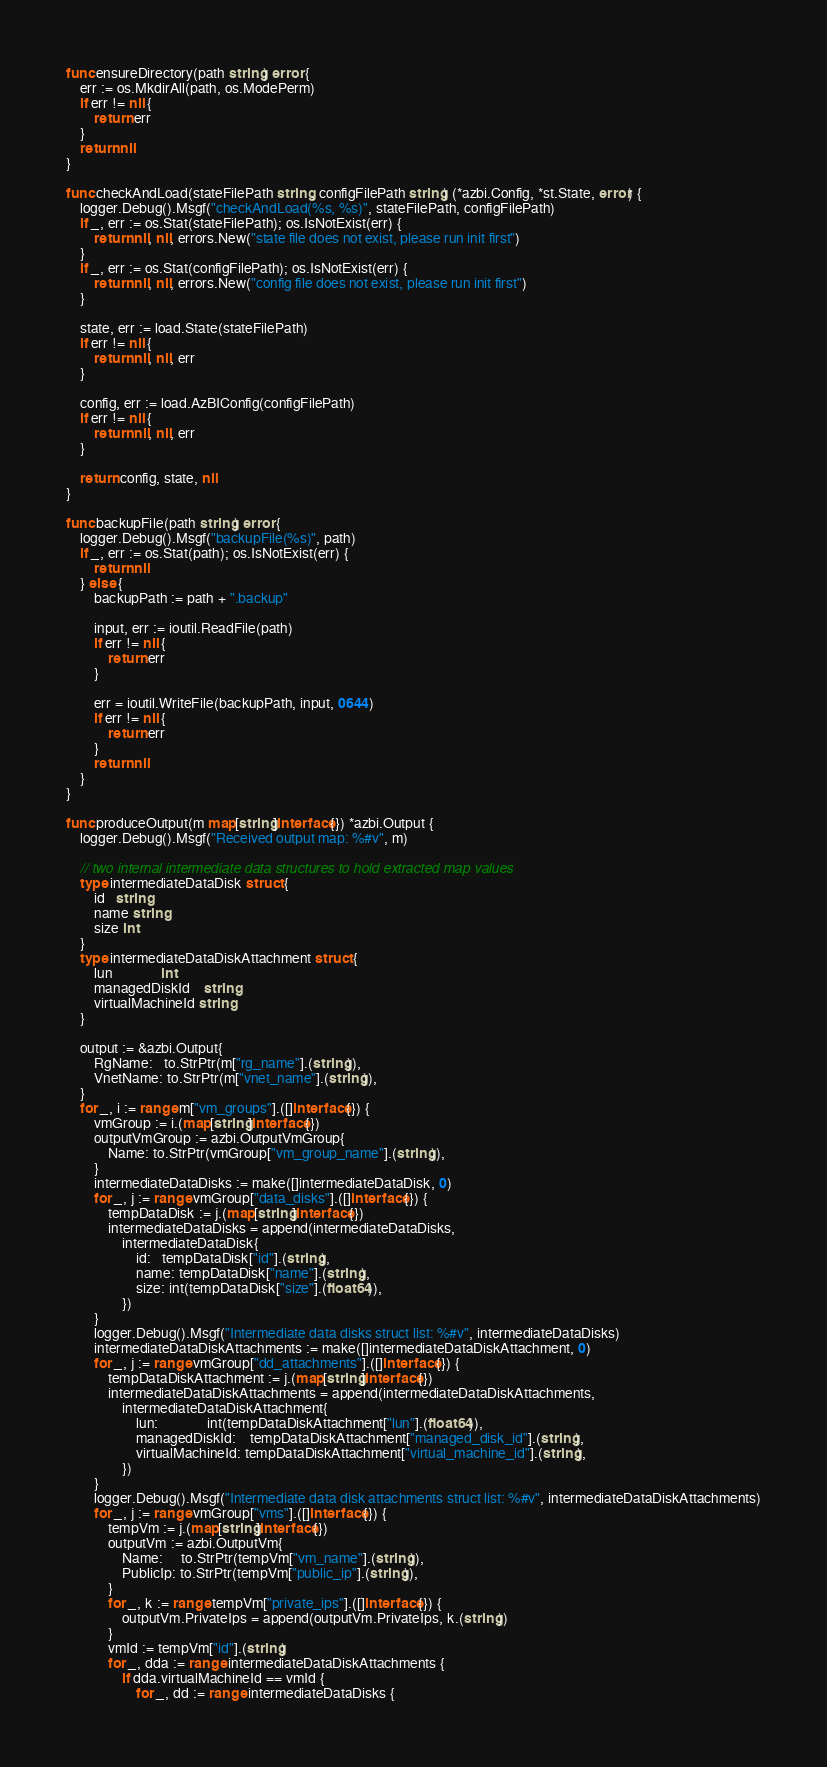Convert code to text. <code><loc_0><loc_0><loc_500><loc_500><_Go_>func ensureDirectory(path string) error {
	err := os.MkdirAll(path, os.ModePerm)
	if err != nil {
		return err
	}
	return nil
}

func checkAndLoad(stateFilePath string, configFilePath string) (*azbi.Config, *st.State, error) {
	logger.Debug().Msgf("checkAndLoad(%s, %s)", stateFilePath, configFilePath)
	if _, err := os.Stat(stateFilePath); os.IsNotExist(err) {
		return nil, nil, errors.New("state file does not exist, please run init first")
	}
	if _, err := os.Stat(configFilePath); os.IsNotExist(err) {
		return nil, nil, errors.New("config file does not exist, please run init first")
	}

	state, err := load.State(stateFilePath)
	if err != nil {
		return nil, nil, err
	}

	config, err := load.AzBIConfig(configFilePath)
	if err != nil {
		return nil, nil, err
	}

	return config, state, nil
}

func backupFile(path string) error {
	logger.Debug().Msgf("backupFile(%s)", path)
	if _, err := os.Stat(path); os.IsNotExist(err) {
		return nil
	} else {
		backupPath := path + ".backup"

		input, err := ioutil.ReadFile(path)
		if err != nil {
			return err
		}

		err = ioutil.WriteFile(backupPath, input, 0644)
		if err != nil {
			return err
		}
		return nil
	}
}

func produceOutput(m map[string]interface{}) *azbi.Output {
	logger.Debug().Msgf("Received output map: %#v", m)

	// two internal intermediate data structures to hold extracted map values
	type intermediateDataDisk struct {
		id   string
		name string
		size int
	}
	type intermediateDataDiskAttachment struct {
		lun              int
		managedDiskId    string
		virtualMachineId string
	}

	output := &azbi.Output{
		RgName:   to.StrPtr(m["rg_name"].(string)),
		VnetName: to.StrPtr(m["vnet_name"].(string)),
	}
	for _, i := range m["vm_groups"].([]interface{}) {
		vmGroup := i.(map[string]interface{})
		outputVmGroup := azbi.OutputVmGroup{
			Name: to.StrPtr(vmGroup["vm_group_name"].(string)),
		}
		intermediateDataDisks := make([]intermediateDataDisk, 0)
		for _, j := range vmGroup["data_disks"].([]interface{}) {
			tempDataDisk := j.(map[string]interface{})
			intermediateDataDisks = append(intermediateDataDisks,
				intermediateDataDisk{
					id:   tempDataDisk["id"].(string),
					name: tempDataDisk["name"].(string),
					size: int(tempDataDisk["size"].(float64)),
				})
		}
		logger.Debug().Msgf("Intermediate data disks struct list: %#v", intermediateDataDisks)
		intermediateDataDiskAttachments := make([]intermediateDataDiskAttachment, 0)
		for _, j := range vmGroup["dd_attachments"].([]interface{}) {
			tempDataDiskAttachment := j.(map[string]interface{})
			intermediateDataDiskAttachments = append(intermediateDataDiskAttachments,
				intermediateDataDiskAttachment{
					lun:              int(tempDataDiskAttachment["lun"].(float64)),
					managedDiskId:    tempDataDiskAttachment["managed_disk_id"].(string),
					virtualMachineId: tempDataDiskAttachment["virtual_machine_id"].(string),
				})
		}
		logger.Debug().Msgf("Intermediate data disk attachments struct list: %#v", intermediateDataDiskAttachments)
		for _, j := range vmGroup["vms"].([]interface{}) {
			tempVm := j.(map[string]interface{})
			outputVm := azbi.OutputVm{
				Name:     to.StrPtr(tempVm["vm_name"].(string)),
				PublicIp: to.StrPtr(tempVm["public_ip"].(string)),
			}
			for _, k := range tempVm["private_ips"].([]interface{}) {
				outputVm.PrivateIps = append(outputVm.PrivateIps, k.(string))
			}
			vmId := tempVm["id"].(string)
			for _, dda := range intermediateDataDiskAttachments {
				if dda.virtualMachineId == vmId {
					for _, dd := range intermediateDataDisks {</code> 